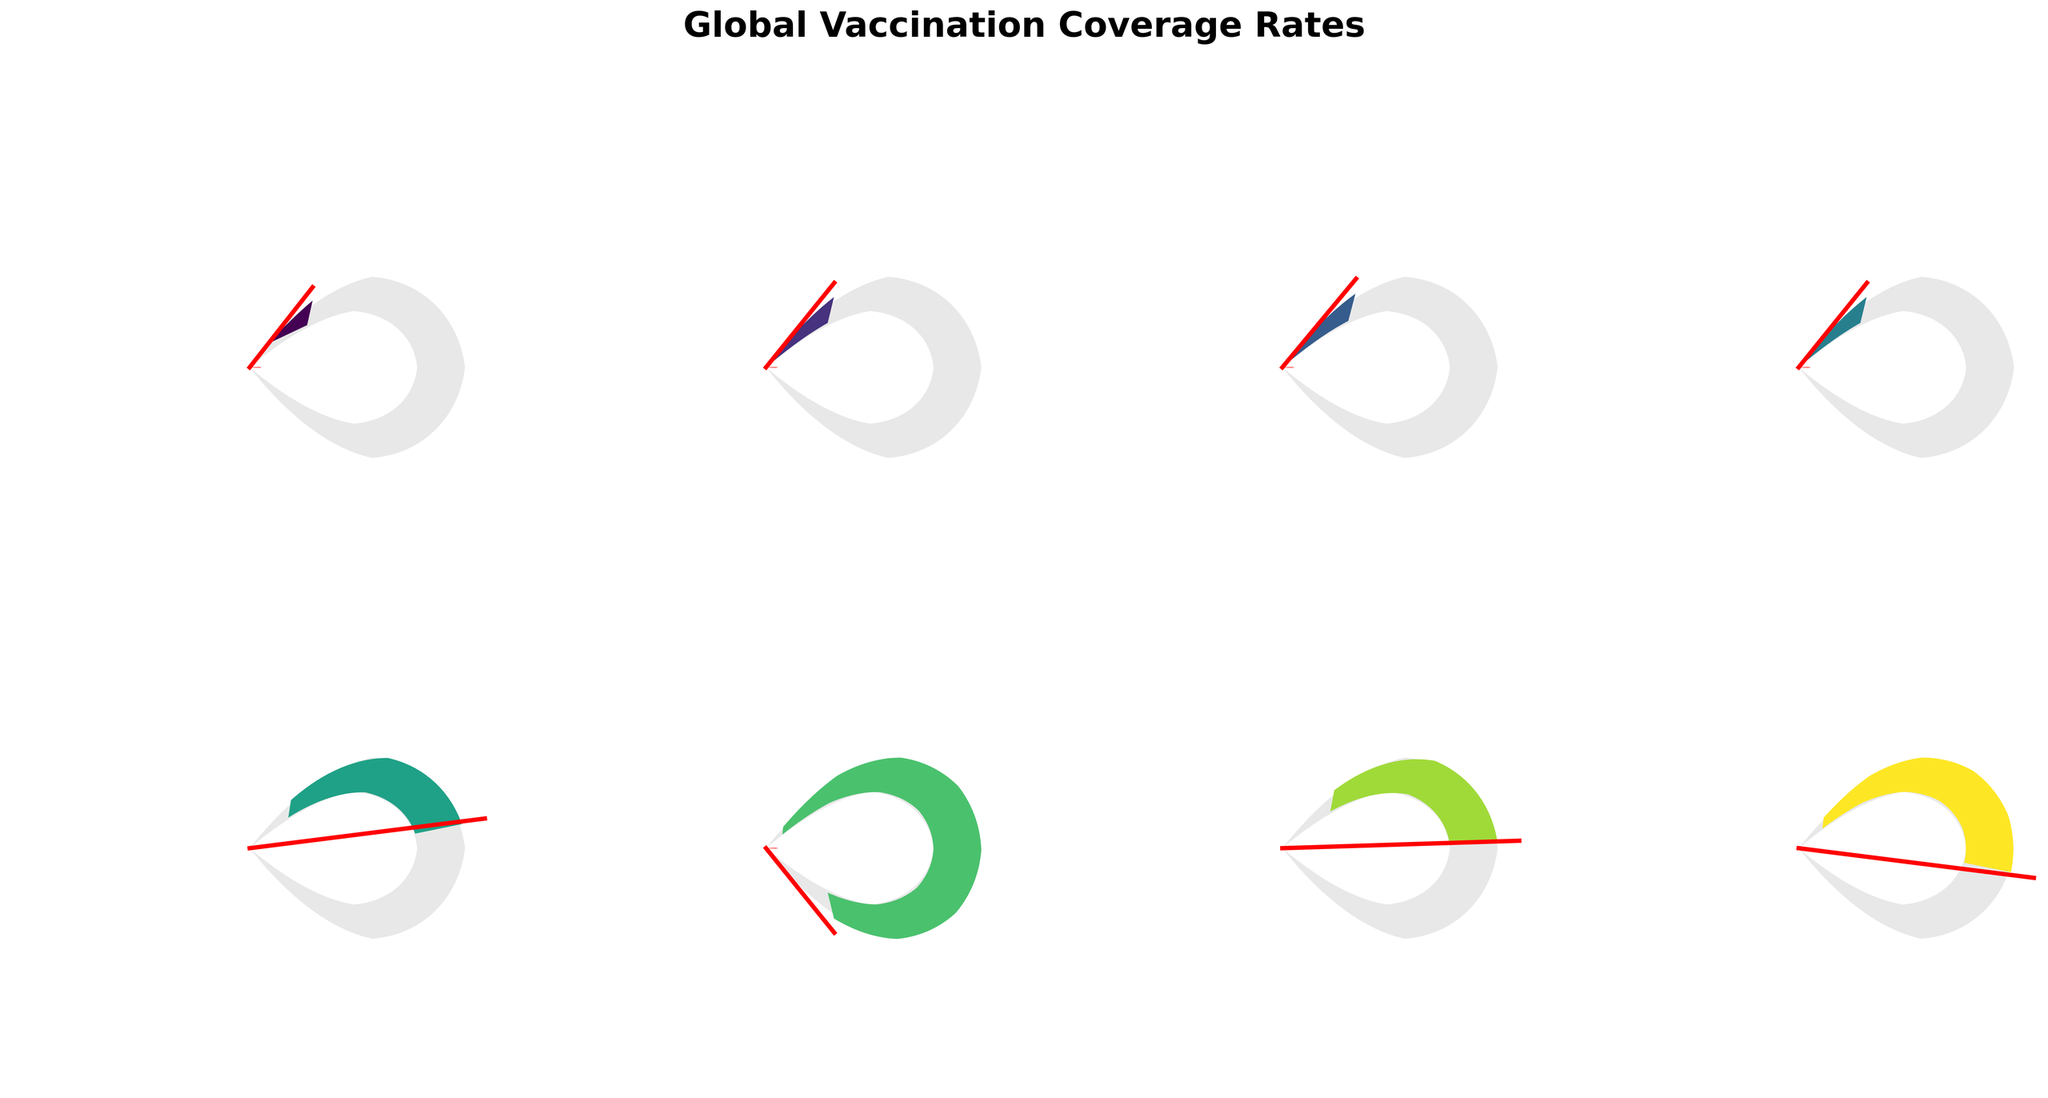Which disease has the highest vaccination coverage rate? The disease with the highest coverage rate corresponds to the gauge with the needle furthest to the right, close to 100% coverage.
Answer: Polio Which disease has the lowest vaccination coverage rate? The disease with the lowest coverage rate corresponds to the gauge with the needle closest to 0% coverage.
Answer: HPV How does the coverage rate for Rotavirus compare to that of Pneumococcal? Compare the positions of the needles for Rotavirus and Pneumococcal; Rotavirus should be slightly higher.
Answer: Rotavirus is higher What is the average vaccination coverage rate for Measles, Hepatitis B, and DTP3? Add the coverage rates for Measles (85%), Hepatitis B (85%), and DTP3 (84%) and divide by 3 to find the average.
Answer: 84.67% Which disease has a coverage rate of 86%? Look for the disease label next to the gauge indicating 86% coverage rate.
Answer: Polio What is the difference between the coverage rates of Yellow Fever and Rotavirus? Subtract the coverage rate of Yellow Fever (46%) from Rotavirus (54%) to find the difference.
Answer: 8% How many diseases have a vaccination coverage rate above 80%? Count the number of gauge charts with needles pointing above 80% coverage rate.
Answer: 4 Is the vaccination coverage rate for Hepatitis B greater than or equal to 85%? Check the gauge representing Hepatitis B and see if the needle is at or above 85%.
Answer: Yes 